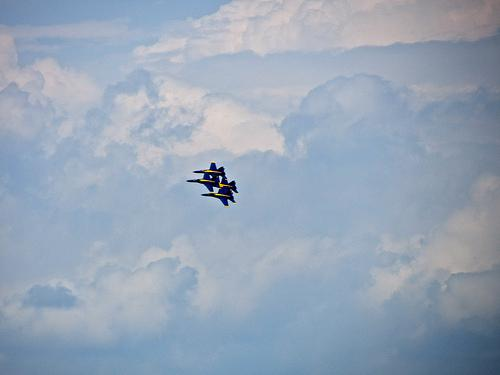Question: where was the photo taken?
Choices:
A. At an art show.
B. At an air show.
C. At a farm.
D. At an auto show.
Answer with the letter. Answer: B Question: what is in the sky?
Choices:
A. Birds.
B. Kites.
C. Jets.
D. Balloons.
Answer with the letter. Answer: C Question: what color is the sky?
Choices:
A. Orange.
B. Gray.
C. Blue.
D. Magenta.
Answer with the letter. Answer: C Question: what is the jet color?
Choices:
A. Pink and white.
B. Green and black.
C. Red, white, and blue.
D. Blue and yellow.
Answer with the letter. Answer: D 